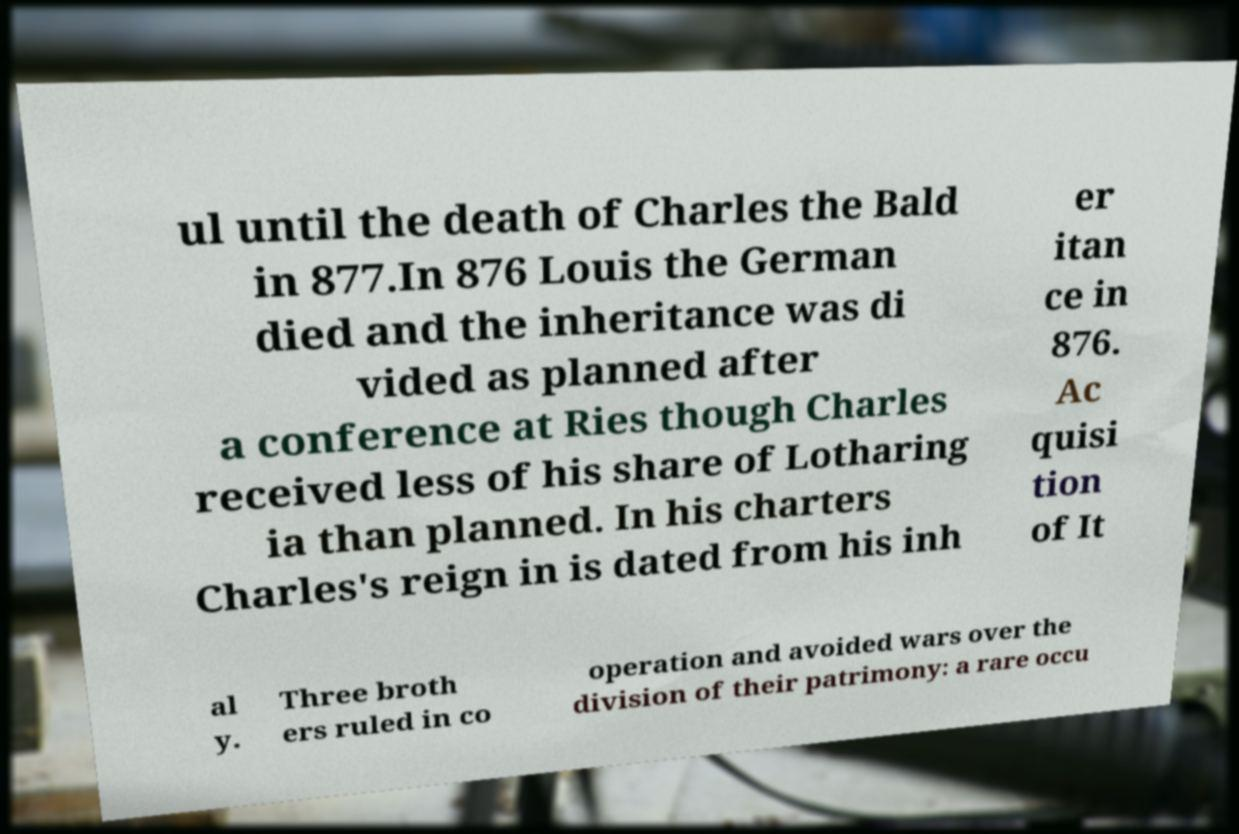I need the written content from this picture converted into text. Can you do that? ul until the death of Charles the Bald in 877.In 876 Louis the German died and the inheritance was di vided as planned after a conference at Ries though Charles received less of his share of Lotharing ia than planned. In his charters Charles's reign in is dated from his inh er itan ce in 876. Ac quisi tion of It al y. Three broth ers ruled in co operation and avoided wars over the division of their patrimony: a rare occu 